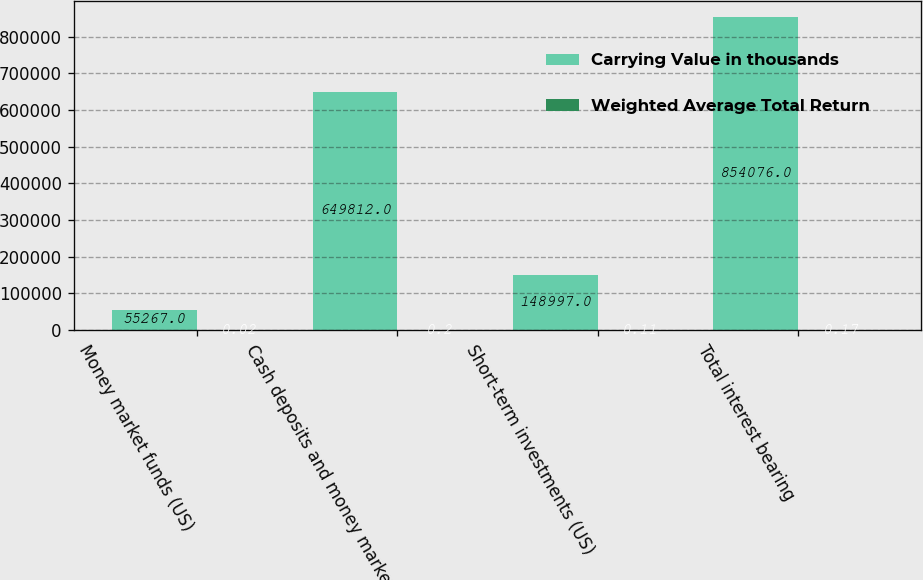Convert chart. <chart><loc_0><loc_0><loc_500><loc_500><stacked_bar_chart><ecel><fcel>Money market funds (US)<fcel>Cash deposits and money market<fcel>Short-term investments (US)<fcel>Total interest bearing<nl><fcel>Carrying Value in thousands<fcel>55267<fcel>649812<fcel>148997<fcel>854076<nl><fcel>Weighted Average Total Return<fcel>0.02<fcel>0.2<fcel>0.11<fcel>0.17<nl></chart> 